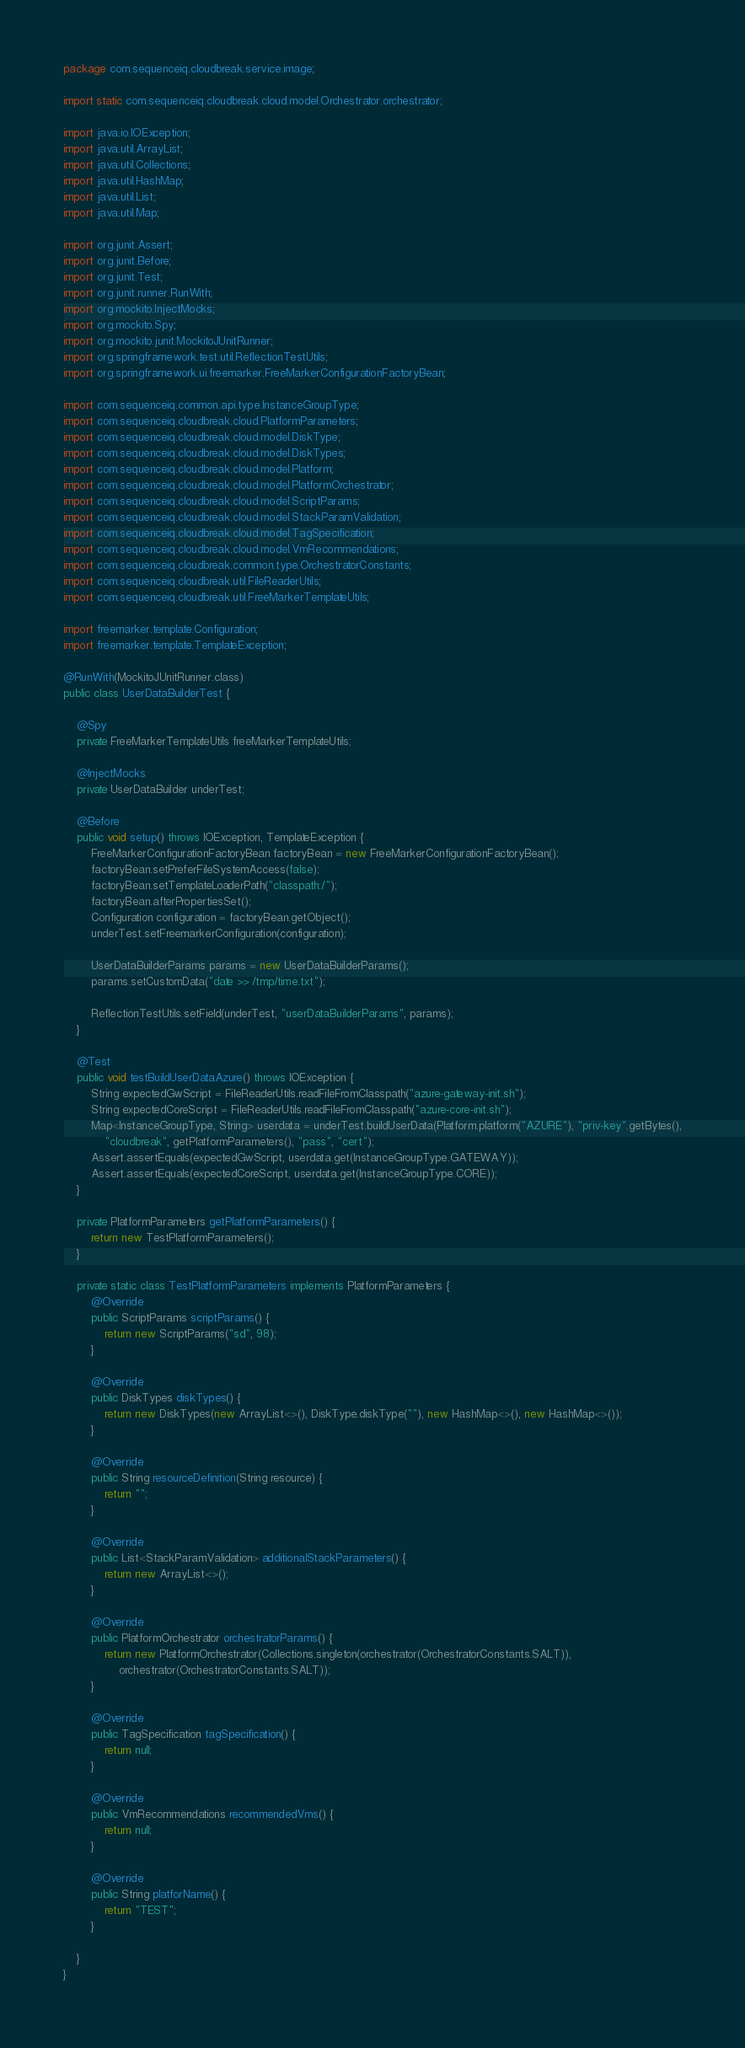<code> <loc_0><loc_0><loc_500><loc_500><_Java_>package com.sequenceiq.cloudbreak.service.image;

import static com.sequenceiq.cloudbreak.cloud.model.Orchestrator.orchestrator;

import java.io.IOException;
import java.util.ArrayList;
import java.util.Collections;
import java.util.HashMap;
import java.util.List;
import java.util.Map;

import org.junit.Assert;
import org.junit.Before;
import org.junit.Test;
import org.junit.runner.RunWith;
import org.mockito.InjectMocks;
import org.mockito.Spy;
import org.mockito.junit.MockitoJUnitRunner;
import org.springframework.test.util.ReflectionTestUtils;
import org.springframework.ui.freemarker.FreeMarkerConfigurationFactoryBean;

import com.sequenceiq.common.api.type.InstanceGroupType;
import com.sequenceiq.cloudbreak.cloud.PlatformParameters;
import com.sequenceiq.cloudbreak.cloud.model.DiskType;
import com.sequenceiq.cloudbreak.cloud.model.DiskTypes;
import com.sequenceiq.cloudbreak.cloud.model.Platform;
import com.sequenceiq.cloudbreak.cloud.model.PlatformOrchestrator;
import com.sequenceiq.cloudbreak.cloud.model.ScriptParams;
import com.sequenceiq.cloudbreak.cloud.model.StackParamValidation;
import com.sequenceiq.cloudbreak.cloud.model.TagSpecification;
import com.sequenceiq.cloudbreak.cloud.model.VmRecommendations;
import com.sequenceiq.cloudbreak.common.type.OrchestratorConstants;
import com.sequenceiq.cloudbreak.util.FileReaderUtils;
import com.sequenceiq.cloudbreak.util.FreeMarkerTemplateUtils;

import freemarker.template.Configuration;
import freemarker.template.TemplateException;

@RunWith(MockitoJUnitRunner.class)
public class UserDataBuilderTest {

    @Spy
    private FreeMarkerTemplateUtils freeMarkerTemplateUtils;

    @InjectMocks
    private UserDataBuilder underTest;

    @Before
    public void setup() throws IOException, TemplateException {
        FreeMarkerConfigurationFactoryBean factoryBean = new FreeMarkerConfigurationFactoryBean();
        factoryBean.setPreferFileSystemAccess(false);
        factoryBean.setTemplateLoaderPath("classpath:/");
        factoryBean.afterPropertiesSet();
        Configuration configuration = factoryBean.getObject();
        underTest.setFreemarkerConfiguration(configuration);

        UserDataBuilderParams params = new UserDataBuilderParams();
        params.setCustomData("date >> /tmp/time.txt");

        ReflectionTestUtils.setField(underTest, "userDataBuilderParams", params);
    }

    @Test
    public void testBuildUserDataAzure() throws IOException {
        String expectedGwScript = FileReaderUtils.readFileFromClasspath("azure-gateway-init.sh");
        String expectedCoreScript = FileReaderUtils.readFileFromClasspath("azure-core-init.sh");
        Map<InstanceGroupType, String> userdata = underTest.buildUserData(Platform.platform("AZURE"), "priv-key".getBytes(),
            "cloudbreak", getPlatformParameters(), "pass", "cert");
        Assert.assertEquals(expectedGwScript, userdata.get(InstanceGroupType.GATEWAY));
        Assert.assertEquals(expectedCoreScript, userdata.get(InstanceGroupType.CORE));
    }

    private PlatformParameters getPlatformParameters() {
        return new TestPlatformParameters();
    }

    private static class TestPlatformParameters implements PlatformParameters {
        @Override
        public ScriptParams scriptParams() {
            return new ScriptParams("sd", 98);
        }

        @Override
        public DiskTypes diskTypes() {
            return new DiskTypes(new ArrayList<>(), DiskType.diskType(""), new HashMap<>(), new HashMap<>());
        }

        @Override
        public String resourceDefinition(String resource) {
            return "";
        }

        @Override
        public List<StackParamValidation> additionalStackParameters() {
            return new ArrayList<>();
        }

        @Override
        public PlatformOrchestrator orchestratorParams() {
            return new PlatformOrchestrator(Collections.singleton(orchestrator(OrchestratorConstants.SALT)),
                orchestrator(OrchestratorConstants.SALT));
        }

        @Override
        public TagSpecification tagSpecification() {
            return null;
        }

        @Override
        public VmRecommendations recommendedVms() {
            return null;
        }

        @Override
        public String platforName() {
            return "TEST";
        }

    }
}
</code> 